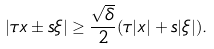<formula> <loc_0><loc_0><loc_500><loc_500>| \tau x \pm s \xi | \geq \frac { \sqrt { \delta } } { 2 } ( \tau | x | + s | \xi | ) .</formula> 